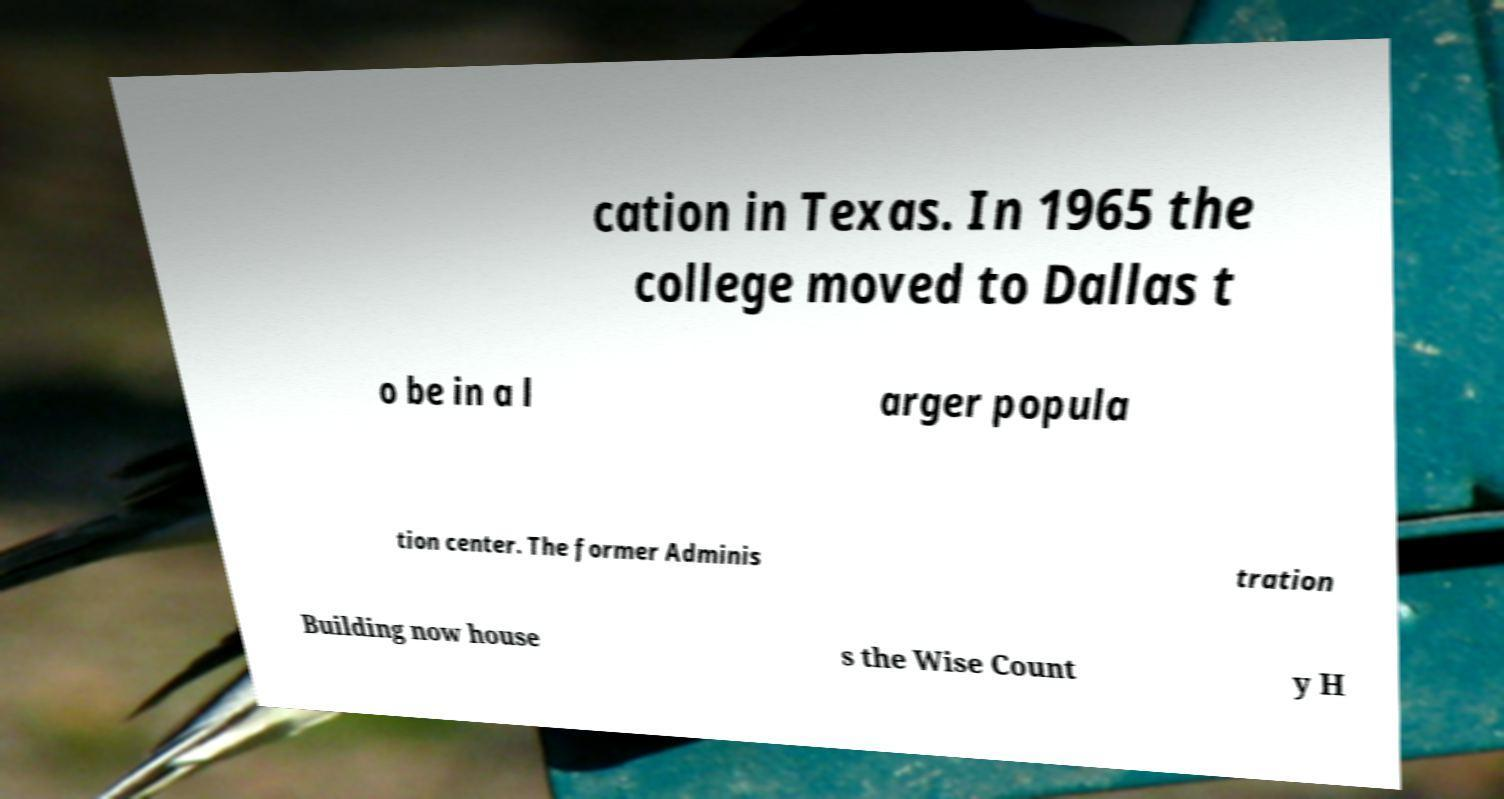Can you accurately transcribe the text from the provided image for me? cation in Texas. In 1965 the college moved to Dallas t o be in a l arger popula tion center. The former Adminis tration Building now house s the Wise Count y H 